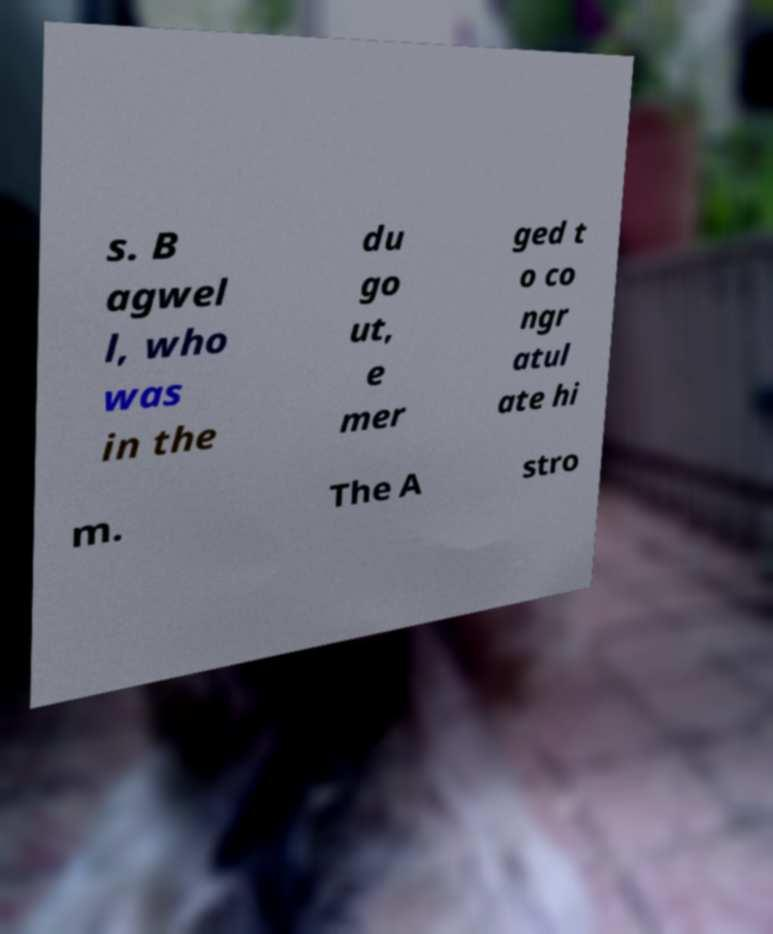For documentation purposes, I need the text within this image transcribed. Could you provide that? s. B agwel l, who was in the du go ut, e mer ged t o co ngr atul ate hi m. The A stro 